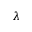<formula> <loc_0><loc_0><loc_500><loc_500>\lambda</formula> 